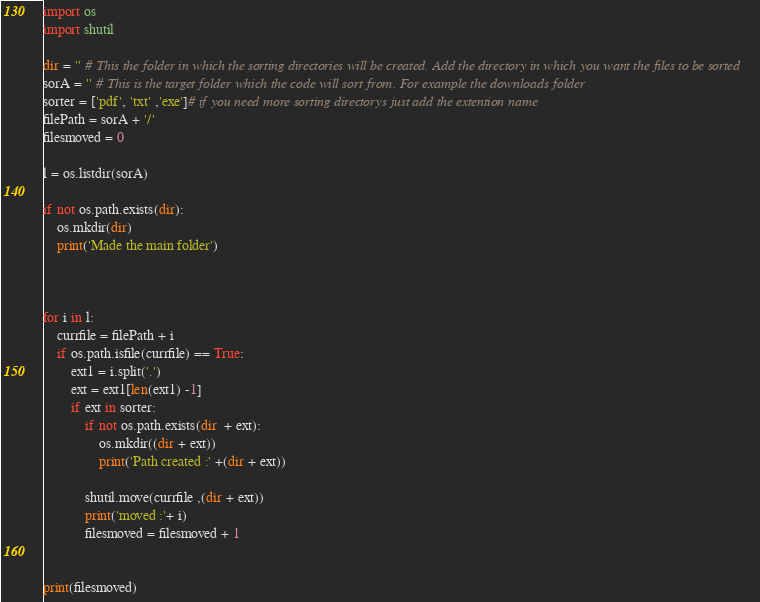<code> <loc_0><loc_0><loc_500><loc_500><_Python_>import os 
import shutil

dir = '' # This the folder in which the sorting directories will be created. Add the directory in which you want the files to be sorted
sorA = '' # This is the target folder which the code will sort from. For example the downloads folder
sorter = ['pdf', 'txt' ,'exe']# if you need more sorting directorys just add the extention name 
filePath = sorA + '/'
filesmoved = 0

l = os.listdir(sorA)

if not os.path.exists(dir):
	os.mkdir(dir)
	print('Made the main folder')



for i in l:
	currfile = filePath + i
	if os.path.isfile(currfile) == True:
		ext1 = i.split('.')
		ext = ext1[len(ext1) -1]
		if ext in sorter:
			if not os.path.exists(dir  + ext):
				os.mkdir((dir + ext))
				print('Path created :' +(dir + ext))

			shutil.move(currfile ,(dir + ext))
			print('moved :'+ i)
			filesmoved = filesmoved + 1


print(filesmoved)
</code> 